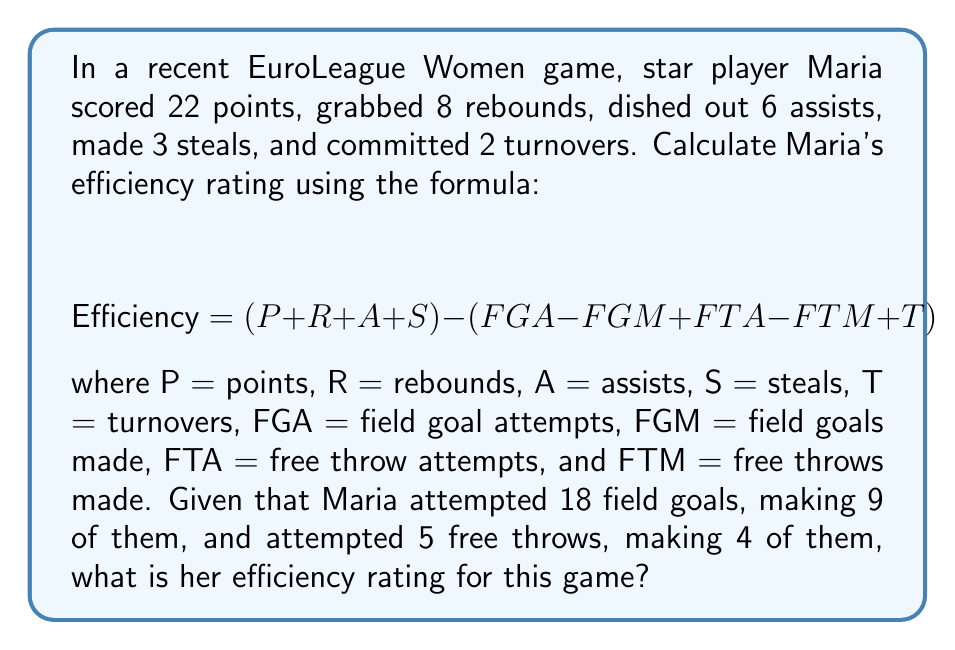Give your solution to this math problem. To solve this problem, we need to follow these steps:

1. Identify the known values:
   P = 22, R = 8, A = 6, S = 3, T = 2
   FGA = 18, FGM = 9, FTA = 5, FTM = 4

2. Apply the efficiency formula:
   $$ \text{Efficiency} = (P + R + A + S) - (FGA - FGM + FTA - FTM + T) $$

3. Substitute the known values:
   $$ \text{Efficiency} = (22 + 8 + 6 + 3) - (18 - 9 + 5 - 4 + 2) $$

4. Calculate the first parenthesis:
   $$ (22 + 8 + 6 + 3) = 39 $$

5. Calculate the second parenthesis:
   $$ (18 - 9 + 5 - 4 + 2) = 12 $$

6. Perform the final subtraction:
   $$ \text{Efficiency} = 39 - 12 = 27 $$

Therefore, Maria's efficiency rating for this game is 27.
Answer: $27$ 